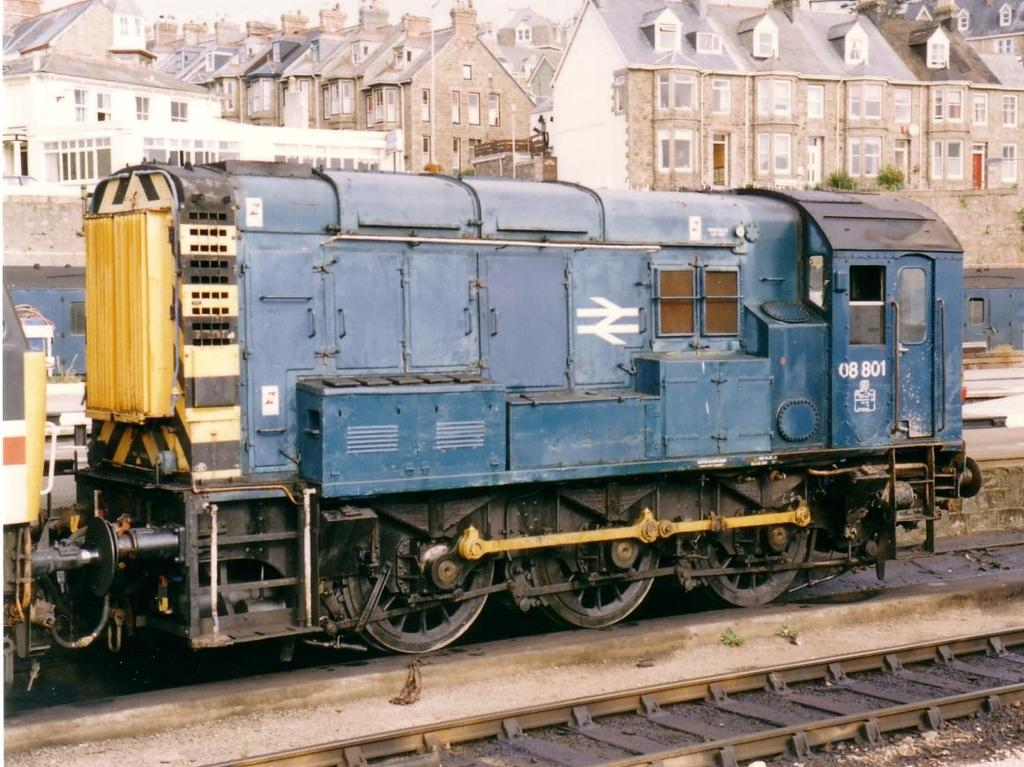What is the main subject in the center of the image? There is a train in the center of the image. What is the train traveling on? The train is traveling on a railway track, which is at the bottom of the image. What can be seen in the background of the image? There are buildings and houses in the background of the image. Are there any natural elements visible in the image? Yes, there are plants visible in the image. What type of straw is being used for teaching in the image? There is no straw or teaching activity present in the image. 